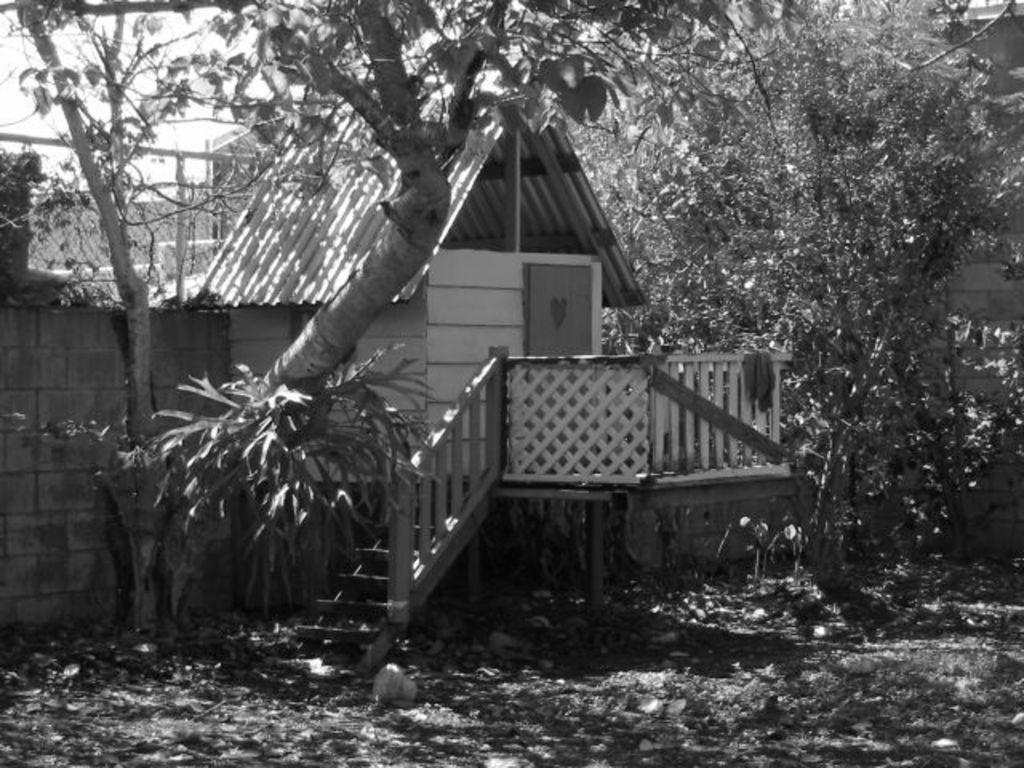What type of structure is visible in the image? There is a house in the image. What can be seen in the background of the image? There are trees and the sky visible in the background of the image. What is the color scheme of the image? The image is in black and white. How many boys are playing near the house in the image? There are no boys present in the image; it only features a house, trees, and the sky. 